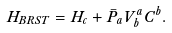Convert formula to latex. <formula><loc_0><loc_0><loc_500><loc_500>H _ { B R S T } = H _ { c } + \bar { P } _ { a } V ^ { a } _ { b } C ^ { b } .</formula> 